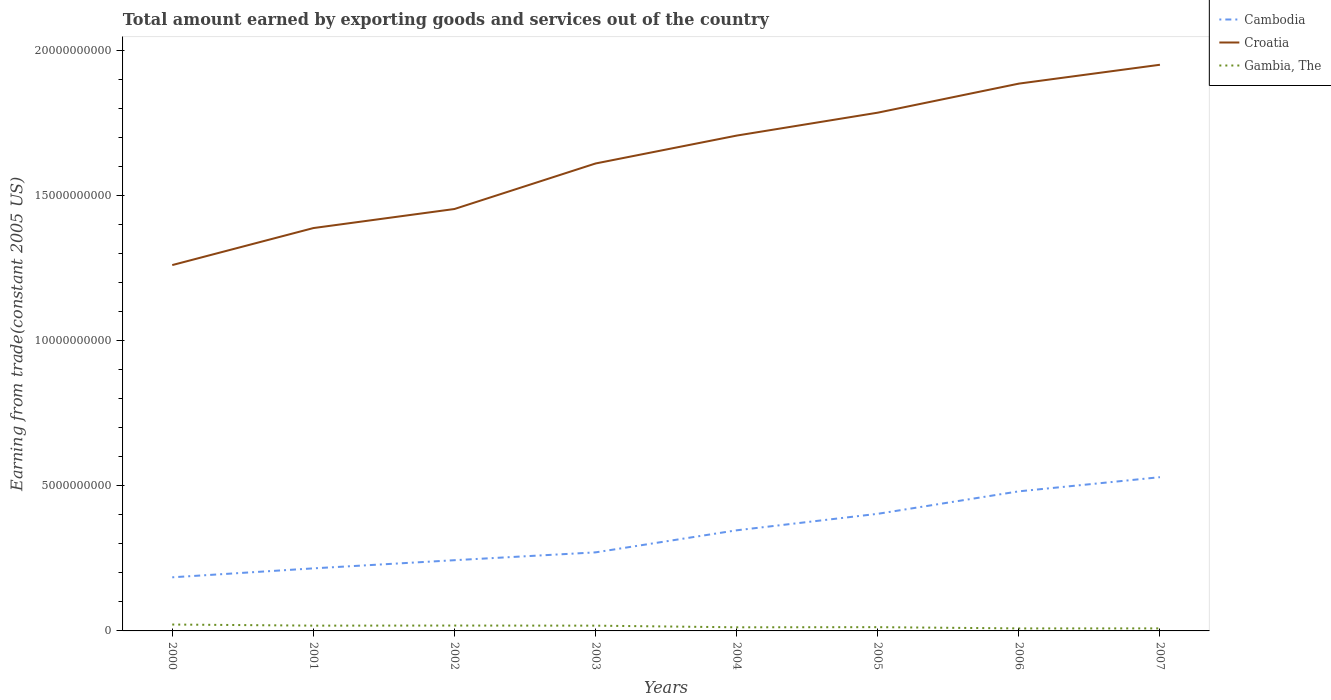How many different coloured lines are there?
Provide a short and direct response. 3. Does the line corresponding to Cambodia intersect with the line corresponding to Gambia, The?
Make the answer very short. No. Across all years, what is the maximum total amount earned by exporting goods and services in Croatia?
Give a very brief answer. 1.26e+1. In which year was the total amount earned by exporting goods and services in Gambia, The maximum?
Provide a short and direct response. 2006. What is the total total amount earned by exporting goods and services in Cambodia in the graph?
Provide a succinct answer. -3.08e+08. What is the difference between the highest and the second highest total amount earned by exporting goods and services in Gambia, The?
Give a very brief answer. 1.34e+08. What is the difference between the highest and the lowest total amount earned by exporting goods and services in Gambia, The?
Your answer should be very brief. 4. How many years are there in the graph?
Your answer should be compact. 8. What is the difference between two consecutive major ticks on the Y-axis?
Keep it short and to the point. 5.00e+09. Are the values on the major ticks of Y-axis written in scientific E-notation?
Provide a short and direct response. No. Does the graph contain any zero values?
Your response must be concise. No. How many legend labels are there?
Provide a short and direct response. 3. What is the title of the graph?
Offer a very short reply. Total amount earned by exporting goods and services out of the country. What is the label or title of the Y-axis?
Offer a very short reply. Earning from trade(constant 2005 US). What is the Earning from trade(constant 2005 US) in Cambodia in 2000?
Make the answer very short. 1.85e+09. What is the Earning from trade(constant 2005 US) in Croatia in 2000?
Your answer should be compact. 1.26e+1. What is the Earning from trade(constant 2005 US) of Gambia, The in 2000?
Give a very brief answer. 2.20e+08. What is the Earning from trade(constant 2005 US) in Cambodia in 2001?
Your response must be concise. 2.15e+09. What is the Earning from trade(constant 2005 US) in Croatia in 2001?
Provide a short and direct response. 1.39e+1. What is the Earning from trade(constant 2005 US) of Gambia, The in 2001?
Offer a very short reply. 1.82e+08. What is the Earning from trade(constant 2005 US) in Cambodia in 2002?
Ensure brevity in your answer.  2.44e+09. What is the Earning from trade(constant 2005 US) of Croatia in 2002?
Offer a terse response. 1.45e+1. What is the Earning from trade(constant 2005 US) of Gambia, The in 2002?
Keep it short and to the point. 1.85e+08. What is the Earning from trade(constant 2005 US) in Cambodia in 2003?
Offer a very short reply. 2.71e+09. What is the Earning from trade(constant 2005 US) of Croatia in 2003?
Offer a very short reply. 1.61e+1. What is the Earning from trade(constant 2005 US) of Gambia, The in 2003?
Keep it short and to the point. 1.81e+08. What is the Earning from trade(constant 2005 US) of Cambodia in 2004?
Your answer should be compact. 3.46e+09. What is the Earning from trade(constant 2005 US) in Croatia in 2004?
Provide a short and direct response. 1.71e+1. What is the Earning from trade(constant 2005 US) in Gambia, The in 2004?
Keep it short and to the point. 1.25e+08. What is the Earning from trade(constant 2005 US) in Cambodia in 2005?
Provide a short and direct response. 4.03e+09. What is the Earning from trade(constant 2005 US) of Croatia in 2005?
Provide a short and direct response. 1.78e+1. What is the Earning from trade(constant 2005 US) in Gambia, The in 2005?
Provide a short and direct response. 1.29e+08. What is the Earning from trade(constant 2005 US) in Cambodia in 2006?
Your answer should be very brief. 4.81e+09. What is the Earning from trade(constant 2005 US) of Croatia in 2006?
Provide a succinct answer. 1.88e+1. What is the Earning from trade(constant 2005 US) in Gambia, The in 2006?
Your answer should be compact. 8.66e+07. What is the Earning from trade(constant 2005 US) of Cambodia in 2007?
Your answer should be very brief. 5.29e+09. What is the Earning from trade(constant 2005 US) in Croatia in 2007?
Keep it short and to the point. 1.95e+1. What is the Earning from trade(constant 2005 US) in Gambia, The in 2007?
Your response must be concise. 8.70e+07. Across all years, what is the maximum Earning from trade(constant 2005 US) of Cambodia?
Keep it short and to the point. 5.29e+09. Across all years, what is the maximum Earning from trade(constant 2005 US) in Croatia?
Provide a succinct answer. 1.95e+1. Across all years, what is the maximum Earning from trade(constant 2005 US) in Gambia, The?
Provide a succinct answer. 2.20e+08. Across all years, what is the minimum Earning from trade(constant 2005 US) of Cambodia?
Offer a very short reply. 1.85e+09. Across all years, what is the minimum Earning from trade(constant 2005 US) of Croatia?
Your answer should be very brief. 1.26e+1. Across all years, what is the minimum Earning from trade(constant 2005 US) in Gambia, The?
Your answer should be compact. 8.66e+07. What is the total Earning from trade(constant 2005 US) in Cambodia in the graph?
Your response must be concise. 2.67e+1. What is the total Earning from trade(constant 2005 US) in Croatia in the graph?
Keep it short and to the point. 1.30e+11. What is the total Earning from trade(constant 2005 US) of Gambia, The in the graph?
Your response must be concise. 1.20e+09. What is the difference between the Earning from trade(constant 2005 US) in Cambodia in 2000 and that in 2001?
Give a very brief answer. -3.08e+08. What is the difference between the Earning from trade(constant 2005 US) of Croatia in 2000 and that in 2001?
Your response must be concise. -1.27e+09. What is the difference between the Earning from trade(constant 2005 US) of Gambia, The in 2000 and that in 2001?
Your answer should be very brief. 3.83e+07. What is the difference between the Earning from trade(constant 2005 US) in Cambodia in 2000 and that in 2002?
Ensure brevity in your answer.  -5.89e+08. What is the difference between the Earning from trade(constant 2005 US) in Croatia in 2000 and that in 2002?
Provide a short and direct response. -1.93e+09. What is the difference between the Earning from trade(constant 2005 US) of Gambia, The in 2000 and that in 2002?
Provide a succinct answer. 3.52e+07. What is the difference between the Earning from trade(constant 2005 US) of Cambodia in 2000 and that in 2003?
Ensure brevity in your answer.  -8.59e+08. What is the difference between the Earning from trade(constant 2005 US) of Croatia in 2000 and that in 2003?
Provide a succinct answer. -3.50e+09. What is the difference between the Earning from trade(constant 2005 US) of Gambia, The in 2000 and that in 2003?
Give a very brief answer. 3.89e+07. What is the difference between the Earning from trade(constant 2005 US) of Cambodia in 2000 and that in 2004?
Keep it short and to the point. -1.62e+09. What is the difference between the Earning from trade(constant 2005 US) in Croatia in 2000 and that in 2004?
Provide a succinct answer. -4.46e+09. What is the difference between the Earning from trade(constant 2005 US) of Gambia, The in 2000 and that in 2004?
Offer a terse response. 9.57e+07. What is the difference between the Earning from trade(constant 2005 US) in Cambodia in 2000 and that in 2005?
Offer a terse response. -2.19e+09. What is the difference between the Earning from trade(constant 2005 US) of Croatia in 2000 and that in 2005?
Ensure brevity in your answer.  -5.25e+09. What is the difference between the Earning from trade(constant 2005 US) in Gambia, The in 2000 and that in 2005?
Provide a succinct answer. 9.07e+07. What is the difference between the Earning from trade(constant 2005 US) in Cambodia in 2000 and that in 2006?
Provide a short and direct response. -2.96e+09. What is the difference between the Earning from trade(constant 2005 US) of Croatia in 2000 and that in 2006?
Provide a succinct answer. -6.25e+09. What is the difference between the Earning from trade(constant 2005 US) in Gambia, The in 2000 and that in 2006?
Offer a terse response. 1.34e+08. What is the difference between the Earning from trade(constant 2005 US) in Cambodia in 2000 and that in 2007?
Your answer should be compact. -3.45e+09. What is the difference between the Earning from trade(constant 2005 US) of Croatia in 2000 and that in 2007?
Ensure brevity in your answer.  -6.90e+09. What is the difference between the Earning from trade(constant 2005 US) in Gambia, The in 2000 and that in 2007?
Your response must be concise. 1.33e+08. What is the difference between the Earning from trade(constant 2005 US) of Cambodia in 2001 and that in 2002?
Your answer should be very brief. -2.81e+08. What is the difference between the Earning from trade(constant 2005 US) of Croatia in 2001 and that in 2002?
Your response must be concise. -6.56e+08. What is the difference between the Earning from trade(constant 2005 US) in Gambia, The in 2001 and that in 2002?
Give a very brief answer. -3.09e+06. What is the difference between the Earning from trade(constant 2005 US) of Cambodia in 2001 and that in 2003?
Your answer should be very brief. -5.51e+08. What is the difference between the Earning from trade(constant 2005 US) in Croatia in 2001 and that in 2003?
Offer a very short reply. -2.22e+09. What is the difference between the Earning from trade(constant 2005 US) in Gambia, The in 2001 and that in 2003?
Keep it short and to the point. 5.71e+05. What is the difference between the Earning from trade(constant 2005 US) in Cambodia in 2001 and that in 2004?
Make the answer very short. -1.31e+09. What is the difference between the Earning from trade(constant 2005 US) of Croatia in 2001 and that in 2004?
Offer a terse response. -3.18e+09. What is the difference between the Earning from trade(constant 2005 US) in Gambia, The in 2001 and that in 2004?
Give a very brief answer. 5.74e+07. What is the difference between the Earning from trade(constant 2005 US) of Cambodia in 2001 and that in 2005?
Offer a very short reply. -1.88e+09. What is the difference between the Earning from trade(constant 2005 US) in Croatia in 2001 and that in 2005?
Offer a terse response. -3.97e+09. What is the difference between the Earning from trade(constant 2005 US) in Gambia, The in 2001 and that in 2005?
Provide a short and direct response. 5.24e+07. What is the difference between the Earning from trade(constant 2005 US) of Cambodia in 2001 and that in 2006?
Your response must be concise. -2.65e+09. What is the difference between the Earning from trade(constant 2005 US) in Croatia in 2001 and that in 2006?
Your answer should be very brief. -4.97e+09. What is the difference between the Earning from trade(constant 2005 US) of Gambia, The in 2001 and that in 2006?
Offer a very short reply. 9.53e+07. What is the difference between the Earning from trade(constant 2005 US) in Cambodia in 2001 and that in 2007?
Give a very brief answer. -3.14e+09. What is the difference between the Earning from trade(constant 2005 US) in Croatia in 2001 and that in 2007?
Your answer should be very brief. -5.62e+09. What is the difference between the Earning from trade(constant 2005 US) of Gambia, The in 2001 and that in 2007?
Your answer should be compact. 9.49e+07. What is the difference between the Earning from trade(constant 2005 US) in Cambodia in 2002 and that in 2003?
Your answer should be very brief. -2.70e+08. What is the difference between the Earning from trade(constant 2005 US) of Croatia in 2002 and that in 2003?
Your answer should be compact. -1.57e+09. What is the difference between the Earning from trade(constant 2005 US) in Gambia, The in 2002 and that in 2003?
Provide a succinct answer. 3.66e+06. What is the difference between the Earning from trade(constant 2005 US) of Cambodia in 2002 and that in 2004?
Give a very brief answer. -1.03e+09. What is the difference between the Earning from trade(constant 2005 US) of Croatia in 2002 and that in 2004?
Keep it short and to the point. -2.53e+09. What is the difference between the Earning from trade(constant 2005 US) of Gambia, The in 2002 and that in 2004?
Make the answer very short. 6.05e+07. What is the difference between the Earning from trade(constant 2005 US) in Cambodia in 2002 and that in 2005?
Provide a succinct answer. -1.60e+09. What is the difference between the Earning from trade(constant 2005 US) of Croatia in 2002 and that in 2005?
Offer a very short reply. -3.32e+09. What is the difference between the Earning from trade(constant 2005 US) of Gambia, The in 2002 and that in 2005?
Your response must be concise. 5.55e+07. What is the difference between the Earning from trade(constant 2005 US) in Cambodia in 2002 and that in 2006?
Give a very brief answer. -2.37e+09. What is the difference between the Earning from trade(constant 2005 US) in Croatia in 2002 and that in 2006?
Offer a terse response. -4.32e+09. What is the difference between the Earning from trade(constant 2005 US) of Gambia, The in 2002 and that in 2006?
Your answer should be very brief. 9.84e+07. What is the difference between the Earning from trade(constant 2005 US) in Cambodia in 2002 and that in 2007?
Your response must be concise. -2.86e+09. What is the difference between the Earning from trade(constant 2005 US) of Croatia in 2002 and that in 2007?
Your response must be concise. -4.97e+09. What is the difference between the Earning from trade(constant 2005 US) in Gambia, The in 2002 and that in 2007?
Give a very brief answer. 9.80e+07. What is the difference between the Earning from trade(constant 2005 US) of Cambodia in 2003 and that in 2004?
Keep it short and to the point. -7.60e+08. What is the difference between the Earning from trade(constant 2005 US) in Croatia in 2003 and that in 2004?
Your response must be concise. -9.60e+08. What is the difference between the Earning from trade(constant 2005 US) in Gambia, The in 2003 and that in 2004?
Your answer should be very brief. 5.68e+07. What is the difference between the Earning from trade(constant 2005 US) of Cambodia in 2003 and that in 2005?
Keep it short and to the point. -1.33e+09. What is the difference between the Earning from trade(constant 2005 US) of Croatia in 2003 and that in 2005?
Provide a succinct answer. -1.75e+09. What is the difference between the Earning from trade(constant 2005 US) in Gambia, The in 2003 and that in 2005?
Keep it short and to the point. 5.18e+07. What is the difference between the Earning from trade(constant 2005 US) of Cambodia in 2003 and that in 2006?
Ensure brevity in your answer.  -2.10e+09. What is the difference between the Earning from trade(constant 2005 US) of Croatia in 2003 and that in 2006?
Keep it short and to the point. -2.75e+09. What is the difference between the Earning from trade(constant 2005 US) of Gambia, The in 2003 and that in 2006?
Ensure brevity in your answer.  9.48e+07. What is the difference between the Earning from trade(constant 2005 US) of Cambodia in 2003 and that in 2007?
Provide a short and direct response. -2.59e+09. What is the difference between the Earning from trade(constant 2005 US) in Croatia in 2003 and that in 2007?
Provide a short and direct response. -3.40e+09. What is the difference between the Earning from trade(constant 2005 US) of Gambia, The in 2003 and that in 2007?
Your answer should be very brief. 9.43e+07. What is the difference between the Earning from trade(constant 2005 US) of Cambodia in 2004 and that in 2005?
Your answer should be very brief. -5.68e+08. What is the difference between the Earning from trade(constant 2005 US) of Croatia in 2004 and that in 2005?
Ensure brevity in your answer.  -7.89e+08. What is the difference between the Earning from trade(constant 2005 US) of Gambia, The in 2004 and that in 2005?
Offer a very short reply. -4.98e+06. What is the difference between the Earning from trade(constant 2005 US) in Cambodia in 2004 and that in 2006?
Your answer should be compact. -1.34e+09. What is the difference between the Earning from trade(constant 2005 US) in Croatia in 2004 and that in 2006?
Provide a short and direct response. -1.79e+09. What is the difference between the Earning from trade(constant 2005 US) in Gambia, The in 2004 and that in 2006?
Offer a terse response. 3.80e+07. What is the difference between the Earning from trade(constant 2005 US) of Cambodia in 2004 and that in 2007?
Your response must be concise. -1.83e+09. What is the difference between the Earning from trade(constant 2005 US) in Croatia in 2004 and that in 2007?
Keep it short and to the point. -2.44e+09. What is the difference between the Earning from trade(constant 2005 US) of Gambia, The in 2004 and that in 2007?
Provide a short and direct response. 3.75e+07. What is the difference between the Earning from trade(constant 2005 US) of Cambodia in 2005 and that in 2006?
Offer a terse response. -7.74e+08. What is the difference between the Earning from trade(constant 2005 US) of Croatia in 2005 and that in 2006?
Offer a very short reply. -1.00e+09. What is the difference between the Earning from trade(constant 2005 US) of Gambia, The in 2005 and that in 2006?
Provide a succinct answer. 4.29e+07. What is the difference between the Earning from trade(constant 2005 US) in Cambodia in 2005 and that in 2007?
Keep it short and to the point. -1.26e+09. What is the difference between the Earning from trade(constant 2005 US) of Croatia in 2005 and that in 2007?
Give a very brief answer. -1.65e+09. What is the difference between the Earning from trade(constant 2005 US) of Gambia, The in 2005 and that in 2007?
Give a very brief answer. 4.25e+07. What is the difference between the Earning from trade(constant 2005 US) of Cambodia in 2006 and that in 2007?
Provide a succinct answer. -4.88e+08. What is the difference between the Earning from trade(constant 2005 US) of Croatia in 2006 and that in 2007?
Offer a terse response. -6.50e+08. What is the difference between the Earning from trade(constant 2005 US) in Gambia, The in 2006 and that in 2007?
Make the answer very short. -4.61e+05. What is the difference between the Earning from trade(constant 2005 US) of Cambodia in 2000 and the Earning from trade(constant 2005 US) of Croatia in 2001?
Offer a terse response. -1.20e+1. What is the difference between the Earning from trade(constant 2005 US) in Cambodia in 2000 and the Earning from trade(constant 2005 US) in Gambia, The in 2001?
Provide a succinct answer. 1.66e+09. What is the difference between the Earning from trade(constant 2005 US) in Croatia in 2000 and the Earning from trade(constant 2005 US) in Gambia, The in 2001?
Your answer should be very brief. 1.24e+1. What is the difference between the Earning from trade(constant 2005 US) in Cambodia in 2000 and the Earning from trade(constant 2005 US) in Croatia in 2002?
Provide a short and direct response. -1.27e+1. What is the difference between the Earning from trade(constant 2005 US) of Cambodia in 2000 and the Earning from trade(constant 2005 US) of Gambia, The in 2002?
Keep it short and to the point. 1.66e+09. What is the difference between the Earning from trade(constant 2005 US) in Croatia in 2000 and the Earning from trade(constant 2005 US) in Gambia, The in 2002?
Offer a very short reply. 1.24e+1. What is the difference between the Earning from trade(constant 2005 US) of Cambodia in 2000 and the Earning from trade(constant 2005 US) of Croatia in 2003?
Ensure brevity in your answer.  -1.43e+1. What is the difference between the Earning from trade(constant 2005 US) of Cambodia in 2000 and the Earning from trade(constant 2005 US) of Gambia, The in 2003?
Offer a terse response. 1.66e+09. What is the difference between the Earning from trade(constant 2005 US) of Croatia in 2000 and the Earning from trade(constant 2005 US) of Gambia, The in 2003?
Offer a terse response. 1.24e+1. What is the difference between the Earning from trade(constant 2005 US) of Cambodia in 2000 and the Earning from trade(constant 2005 US) of Croatia in 2004?
Provide a succinct answer. -1.52e+1. What is the difference between the Earning from trade(constant 2005 US) of Cambodia in 2000 and the Earning from trade(constant 2005 US) of Gambia, The in 2004?
Provide a short and direct response. 1.72e+09. What is the difference between the Earning from trade(constant 2005 US) of Croatia in 2000 and the Earning from trade(constant 2005 US) of Gambia, The in 2004?
Provide a succinct answer. 1.25e+1. What is the difference between the Earning from trade(constant 2005 US) in Cambodia in 2000 and the Earning from trade(constant 2005 US) in Croatia in 2005?
Ensure brevity in your answer.  -1.60e+1. What is the difference between the Earning from trade(constant 2005 US) of Cambodia in 2000 and the Earning from trade(constant 2005 US) of Gambia, The in 2005?
Provide a succinct answer. 1.72e+09. What is the difference between the Earning from trade(constant 2005 US) of Croatia in 2000 and the Earning from trade(constant 2005 US) of Gambia, The in 2005?
Offer a terse response. 1.25e+1. What is the difference between the Earning from trade(constant 2005 US) of Cambodia in 2000 and the Earning from trade(constant 2005 US) of Croatia in 2006?
Offer a terse response. -1.70e+1. What is the difference between the Earning from trade(constant 2005 US) of Cambodia in 2000 and the Earning from trade(constant 2005 US) of Gambia, The in 2006?
Provide a succinct answer. 1.76e+09. What is the difference between the Earning from trade(constant 2005 US) of Croatia in 2000 and the Earning from trade(constant 2005 US) of Gambia, The in 2006?
Provide a succinct answer. 1.25e+1. What is the difference between the Earning from trade(constant 2005 US) in Cambodia in 2000 and the Earning from trade(constant 2005 US) in Croatia in 2007?
Provide a short and direct response. -1.77e+1. What is the difference between the Earning from trade(constant 2005 US) of Cambodia in 2000 and the Earning from trade(constant 2005 US) of Gambia, The in 2007?
Keep it short and to the point. 1.76e+09. What is the difference between the Earning from trade(constant 2005 US) in Croatia in 2000 and the Earning from trade(constant 2005 US) in Gambia, The in 2007?
Your answer should be compact. 1.25e+1. What is the difference between the Earning from trade(constant 2005 US) of Cambodia in 2001 and the Earning from trade(constant 2005 US) of Croatia in 2002?
Provide a short and direct response. -1.24e+1. What is the difference between the Earning from trade(constant 2005 US) in Cambodia in 2001 and the Earning from trade(constant 2005 US) in Gambia, The in 2002?
Ensure brevity in your answer.  1.97e+09. What is the difference between the Earning from trade(constant 2005 US) in Croatia in 2001 and the Earning from trade(constant 2005 US) in Gambia, The in 2002?
Offer a terse response. 1.37e+1. What is the difference between the Earning from trade(constant 2005 US) of Cambodia in 2001 and the Earning from trade(constant 2005 US) of Croatia in 2003?
Offer a terse response. -1.39e+1. What is the difference between the Earning from trade(constant 2005 US) of Cambodia in 2001 and the Earning from trade(constant 2005 US) of Gambia, The in 2003?
Your answer should be compact. 1.97e+09. What is the difference between the Earning from trade(constant 2005 US) of Croatia in 2001 and the Earning from trade(constant 2005 US) of Gambia, The in 2003?
Keep it short and to the point. 1.37e+1. What is the difference between the Earning from trade(constant 2005 US) of Cambodia in 2001 and the Earning from trade(constant 2005 US) of Croatia in 2004?
Keep it short and to the point. -1.49e+1. What is the difference between the Earning from trade(constant 2005 US) of Cambodia in 2001 and the Earning from trade(constant 2005 US) of Gambia, The in 2004?
Your response must be concise. 2.03e+09. What is the difference between the Earning from trade(constant 2005 US) in Croatia in 2001 and the Earning from trade(constant 2005 US) in Gambia, The in 2004?
Ensure brevity in your answer.  1.37e+1. What is the difference between the Earning from trade(constant 2005 US) of Cambodia in 2001 and the Earning from trade(constant 2005 US) of Croatia in 2005?
Offer a terse response. -1.57e+1. What is the difference between the Earning from trade(constant 2005 US) in Cambodia in 2001 and the Earning from trade(constant 2005 US) in Gambia, The in 2005?
Provide a short and direct response. 2.02e+09. What is the difference between the Earning from trade(constant 2005 US) of Croatia in 2001 and the Earning from trade(constant 2005 US) of Gambia, The in 2005?
Provide a short and direct response. 1.37e+1. What is the difference between the Earning from trade(constant 2005 US) of Cambodia in 2001 and the Earning from trade(constant 2005 US) of Croatia in 2006?
Ensure brevity in your answer.  -1.67e+1. What is the difference between the Earning from trade(constant 2005 US) in Cambodia in 2001 and the Earning from trade(constant 2005 US) in Gambia, The in 2006?
Give a very brief answer. 2.07e+09. What is the difference between the Earning from trade(constant 2005 US) in Croatia in 2001 and the Earning from trade(constant 2005 US) in Gambia, The in 2006?
Offer a very short reply. 1.38e+1. What is the difference between the Earning from trade(constant 2005 US) of Cambodia in 2001 and the Earning from trade(constant 2005 US) of Croatia in 2007?
Your answer should be very brief. -1.73e+1. What is the difference between the Earning from trade(constant 2005 US) of Cambodia in 2001 and the Earning from trade(constant 2005 US) of Gambia, The in 2007?
Your response must be concise. 2.07e+09. What is the difference between the Earning from trade(constant 2005 US) of Croatia in 2001 and the Earning from trade(constant 2005 US) of Gambia, The in 2007?
Offer a terse response. 1.38e+1. What is the difference between the Earning from trade(constant 2005 US) in Cambodia in 2002 and the Earning from trade(constant 2005 US) in Croatia in 2003?
Ensure brevity in your answer.  -1.37e+1. What is the difference between the Earning from trade(constant 2005 US) of Cambodia in 2002 and the Earning from trade(constant 2005 US) of Gambia, The in 2003?
Keep it short and to the point. 2.25e+09. What is the difference between the Earning from trade(constant 2005 US) of Croatia in 2002 and the Earning from trade(constant 2005 US) of Gambia, The in 2003?
Your response must be concise. 1.43e+1. What is the difference between the Earning from trade(constant 2005 US) in Cambodia in 2002 and the Earning from trade(constant 2005 US) in Croatia in 2004?
Your answer should be very brief. -1.46e+1. What is the difference between the Earning from trade(constant 2005 US) of Cambodia in 2002 and the Earning from trade(constant 2005 US) of Gambia, The in 2004?
Ensure brevity in your answer.  2.31e+09. What is the difference between the Earning from trade(constant 2005 US) in Croatia in 2002 and the Earning from trade(constant 2005 US) in Gambia, The in 2004?
Keep it short and to the point. 1.44e+1. What is the difference between the Earning from trade(constant 2005 US) of Cambodia in 2002 and the Earning from trade(constant 2005 US) of Croatia in 2005?
Ensure brevity in your answer.  -1.54e+1. What is the difference between the Earning from trade(constant 2005 US) of Cambodia in 2002 and the Earning from trade(constant 2005 US) of Gambia, The in 2005?
Provide a succinct answer. 2.31e+09. What is the difference between the Earning from trade(constant 2005 US) in Croatia in 2002 and the Earning from trade(constant 2005 US) in Gambia, The in 2005?
Keep it short and to the point. 1.44e+1. What is the difference between the Earning from trade(constant 2005 US) of Cambodia in 2002 and the Earning from trade(constant 2005 US) of Croatia in 2006?
Your answer should be very brief. -1.64e+1. What is the difference between the Earning from trade(constant 2005 US) of Cambodia in 2002 and the Earning from trade(constant 2005 US) of Gambia, The in 2006?
Your response must be concise. 2.35e+09. What is the difference between the Earning from trade(constant 2005 US) of Croatia in 2002 and the Earning from trade(constant 2005 US) of Gambia, The in 2006?
Offer a very short reply. 1.44e+1. What is the difference between the Earning from trade(constant 2005 US) in Cambodia in 2002 and the Earning from trade(constant 2005 US) in Croatia in 2007?
Offer a terse response. -1.71e+1. What is the difference between the Earning from trade(constant 2005 US) of Cambodia in 2002 and the Earning from trade(constant 2005 US) of Gambia, The in 2007?
Make the answer very short. 2.35e+09. What is the difference between the Earning from trade(constant 2005 US) in Croatia in 2002 and the Earning from trade(constant 2005 US) in Gambia, The in 2007?
Keep it short and to the point. 1.44e+1. What is the difference between the Earning from trade(constant 2005 US) in Cambodia in 2003 and the Earning from trade(constant 2005 US) in Croatia in 2004?
Provide a succinct answer. -1.44e+1. What is the difference between the Earning from trade(constant 2005 US) in Cambodia in 2003 and the Earning from trade(constant 2005 US) in Gambia, The in 2004?
Keep it short and to the point. 2.58e+09. What is the difference between the Earning from trade(constant 2005 US) of Croatia in 2003 and the Earning from trade(constant 2005 US) of Gambia, The in 2004?
Keep it short and to the point. 1.60e+1. What is the difference between the Earning from trade(constant 2005 US) in Cambodia in 2003 and the Earning from trade(constant 2005 US) in Croatia in 2005?
Make the answer very short. -1.51e+1. What is the difference between the Earning from trade(constant 2005 US) in Cambodia in 2003 and the Earning from trade(constant 2005 US) in Gambia, The in 2005?
Give a very brief answer. 2.58e+09. What is the difference between the Earning from trade(constant 2005 US) of Croatia in 2003 and the Earning from trade(constant 2005 US) of Gambia, The in 2005?
Provide a short and direct response. 1.60e+1. What is the difference between the Earning from trade(constant 2005 US) of Cambodia in 2003 and the Earning from trade(constant 2005 US) of Croatia in 2006?
Provide a succinct answer. -1.61e+1. What is the difference between the Earning from trade(constant 2005 US) in Cambodia in 2003 and the Earning from trade(constant 2005 US) in Gambia, The in 2006?
Provide a short and direct response. 2.62e+09. What is the difference between the Earning from trade(constant 2005 US) of Croatia in 2003 and the Earning from trade(constant 2005 US) of Gambia, The in 2006?
Offer a terse response. 1.60e+1. What is the difference between the Earning from trade(constant 2005 US) in Cambodia in 2003 and the Earning from trade(constant 2005 US) in Croatia in 2007?
Make the answer very short. -1.68e+1. What is the difference between the Earning from trade(constant 2005 US) of Cambodia in 2003 and the Earning from trade(constant 2005 US) of Gambia, The in 2007?
Provide a succinct answer. 2.62e+09. What is the difference between the Earning from trade(constant 2005 US) of Croatia in 2003 and the Earning from trade(constant 2005 US) of Gambia, The in 2007?
Your answer should be compact. 1.60e+1. What is the difference between the Earning from trade(constant 2005 US) of Cambodia in 2004 and the Earning from trade(constant 2005 US) of Croatia in 2005?
Keep it short and to the point. -1.44e+1. What is the difference between the Earning from trade(constant 2005 US) in Cambodia in 2004 and the Earning from trade(constant 2005 US) in Gambia, The in 2005?
Provide a succinct answer. 3.34e+09. What is the difference between the Earning from trade(constant 2005 US) of Croatia in 2004 and the Earning from trade(constant 2005 US) of Gambia, The in 2005?
Give a very brief answer. 1.69e+1. What is the difference between the Earning from trade(constant 2005 US) in Cambodia in 2004 and the Earning from trade(constant 2005 US) in Croatia in 2006?
Give a very brief answer. -1.54e+1. What is the difference between the Earning from trade(constant 2005 US) in Cambodia in 2004 and the Earning from trade(constant 2005 US) in Gambia, The in 2006?
Your answer should be compact. 3.38e+09. What is the difference between the Earning from trade(constant 2005 US) in Croatia in 2004 and the Earning from trade(constant 2005 US) in Gambia, The in 2006?
Offer a terse response. 1.70e+1. What is the difference between the Earning from trade(constant 2005 US) in Cambodia in 2004 and the Earning from trade(constant 2005 US) in Croatia in 2007?
Make the answer very short. -1.60e+1. What is the difference between the Earning from trade(constant 2005 US) in Cambodia in 2004 and the Earning from trade(constant 2005 US) in Gambia, The in 2007?
Provide a succinct answer. 3.38e+09. What is the difference between the Earning from trade(constant 2005 US) in Croatia in 2004 and the Earning from trade(constant 2005 US) in Gambia, The in 2007?
Provide a short and direct response. 1.70e+1. What is the difference between the Earning from trade(constant 2005 US) in Cambodia in 2005 and the Earning from trade(constant 2005 US) in Croatia in 2006?
Give a very brief answer. -1.48e+1. What is the difference between the Earning from trade(constant 2005 US) of Cambodia in 2005 and the Earning from trade(constant 2005 US) of Gambia, The in 2006?
Keep it short and to the point. 3.95e+09. What is the difference between the Earning from trade(constant 2005 US) of Croatia in 2005 and the Earning from trade(constant 2005 US) of Gambia, The in 2006?
Ensure brevity in your answer.  1.78e+1. What is the difference between the Earning from trade(constant 2005 US) in Cambodia in 2005 and the Earning from trade(constant 2005 US) in Croatia in 2007?
Provide a short and direct response. -1.55e+1. What is the difference between the Earning from trade(constant 2005 US) of Cambodia in 2005 and the Earning from trade(constant 2005 US) of Gambia, The in 2007?
Make the answer very short. 3.95e+09. What is the difference between the Earning from trade(constant 2005 US) of Croatia in 2005 and the Earning from trade(constant 2005 US) of Gambia, The in 2007?
Your response must be concise. 1.78e+1. What is the difference between the Earning from trade(constant 2005 US) of Cambodia in 2006 and the Earning from trade(constant 2005 US) of Croatia in 2007?
Provide a succinct answer. -1.47e+1. What is the difference between the Earning from trade(constant 2005 US) in Cambodia in 2006 and the Earning from trade(constant 2005 US) in Gambia, The in 2007?
Ensure brevity in your answer.  4.72e+09. What is the difference between the Earning from trade(constant 2005 US) of Croatia in 2006 and the Earning from trade(constant 2005 US) of Gambia, The in 2007?
Your answer should be very brief. 1.88e+1. What is the average Earning from trade(constant 2005 US) in Cambodia per year?
Keep it short and to the point. 3.34e+09. What is the average Earning from trade(constant 2005 US) in Croatia per year?
Provide a short and direct response. 1.63e+1. What is the average Earning from trade(constant 2005 US) in Gambia, The per year?
Ensure brevity in your answer.  1.49e+08. In the year 2000, what is the difference between the Earning from trade(constant 2005 US) in Cambodia and Earning from trade(constant 2005 US) in Croatia?
Make the answer very short. -1.08e+1. In the year 2000, what is the difference between the Earning from trade(constant 2005 US) in Cambodia and Earning from trade(constant 2005 US) in Gambia, The?
Keep it short and to the point. 1.63e+09. In the year 2000, what is the difference between the Earning from trade(constant 2005 US) of Croatia and Earning from trade(constant 2005 US) of Gambia, The?
Provide a short and direct response. 1.24e+1. In the year 2001, what is the difference between the Earning from trade(constant 2005 US) in Cambodia and Earning from trade(constant 2005 US) in Croatia?
Your answer should be very brief. -1.17e+1. In the year 2001, what is the difference between the Earning from trade(constant 2005 US) in Cambodia and Earning from trade(constant 2005 US) in Gambia, The?
Give a very brief answer. 1.97e+09. In the year 2001, what is the difference between the Earning from trade(constant 2005 US) of Croatia and Earning from trade(constant 2005 US) of Gambia, The?
Keep it short and to the point. 1.37e+1. In the year 2002, what is the difference between the Earning from trade(constant 2005 US) of Cambodia and Earning from trade(constant 2005 US) of Croatia?
Your answer should be very brief. -1.21e+1. In the year 2002, what is the difference between the Earning from trade(constant 2005 US) of Cambodia and Earning from trade(constant 2005 US) of Gambia, The?
Ensure brevity in your answer.  2.25e+09. In the year 2002, what is the difference between the Earning from trade(constant 2005 US) of Croatia and Earning from trade(constant 2005 US) of Gambia, The?
Ensure brevity in your answer.  1.43e+1. In the year 2003, what is the difference between the Earning from trade(constant 2005 US) of Cambodia and Earning from trade(constant 2005 US) of Croatia?
Your answer should be very brief. -1.34e+1. In the year 2003, what is the difference between the Earning from trade(constant 2005 US) of Cambodia and Earning from trade(constant 2005 US) of Gambia, The?
Give a very brief answer. 2.52e+09. In the year 2003, what is the difference between the Earning from trade(constant 2005 US) of Croatia and Earning from trade(constant 2005 US) of Gambia, The?
Your response must be concise. 1.59e+1. In the year 2004, what is the difference between the Earning from trade(constant 2005 US) of Cambodia and Earning from trade(constant 2005 US) of Croatia?
Provide a succinct answer. -1.36e+1. In the year 2004, what is the difference between the Earning from trade(constant 2005 US) of Cambodia and Earning from trade(constant 2005 US) of Gambia, The?
Your answer should be very brief. 3.34e+09. In the year 2004, what is the difference between the Earning from trade(constant 2005 US) in Croatia and Earning from trade(constant 2005 US) in Gambia, The?
Your answer should be very brief. 1.69e+1. In the year 2005, what is the difference between the Earning from trade(constant 2005 US) of Cambodia and Earning from trade(constant 2005 US) of Croatia?
Make the answer very short. -1.38e+1. In the year 2005, what is the difference between the Earning from trade(constant 2005 US) of Cambodia and Earning from trade(constant 2005 US) of Gambia, The?
Ensure brevity in your answer.  3.90e+09. In the year 2005, what is the difference between the Earning from trade(constant 2005 US) in Croatia and Earning from trade(constant 2005 US) in Gambia, The?
Provide a short and direct response. 1.77e+1. In the year 2006, what is the difference between the Earning from trade(constant 2005 US) of Cambodia and Earning from trade(constant 2005 US) of Croatia?
Offer a terse response. -1.40e+1. In the year 2006, what is the difference between the Earning from trade(constant 2005 US) in Cambodia and Earning from trade(constant 2005 US) in Gambia, The?
Your answer should be compact. 4.72e+09. In the year 2006, what is the difference between the Earning from trade(constant 2005 US) in Croatia and Earning from trade(constant 2005 US) in Gambia, The?
Your answer should be very brief. 1.88e+1. In the year 2007, what is the difference between the Earning from trade(constant 2005 US) in Cambodia and Earning from trade(constant 2005 US) in Croatia?
Provide a succinct answer. -1.42e+1. In the year 2007, what is the difference between the Earning from trade(constant 2005 US) of Cambodia and Earning from trade(constant 2005 US) of Gambia, The?
Provide a short and direct response. 5.21e+09. In the year 2007, what is the difference between the Earning from trade(constant 2005 US) in Croatia and Earning from trade(constant 2005 US) in Gambia, The?
Make the answer very short. 1.94e+1. What is the ratio of the Earning from trade(constant 2005 US) in Cambodia in 2000 to that in 2001?
Your answer should be compact. 0.86. What is the ratio of the Earning from trade(constant 2005 US) in Croatia in 2000 to that in 2001?
Provide a short and direct response. 0.91. What is the ratio of the Earning from trade(constant 2005 US) in Gambia, The in 2000 to that in 2001?
Provide a succinct answer. 1.21. What is the ratio of the Earning from trade(constant 2005 US) of Cambodia in 2000 to that in 2002?
Provide a short and direct response. 0.76. What is the ratio of the Earning from trade(constant 2005 US) in Croatia in 2000 to that in 2002?
Provide a succinct answer. 0.87. What is the ratio of the Earning from trade(constant 2005 US) in Gambia, The in 2000 to that in 2002?
Provide a short and direct response. 1.19. What is the ratio of the Earning from trade(constant 2005 US) of Cambodia in 2000 to that in 2003?
Offer a terse response. 0.68. What is the ratio of the Earning from trade(constant 2005 US) in Croatia in 2000 to that in 2003?
Ensure brevity in your answer.  0.78. What is the ratio of the Earning from trade(constant 2005 US) of Gambia, The in 2000 to that in 2003?
Offer a very short reply. 1.21. What is the ratio of the Earning from trade(constant 2005 US) of Cambodia in 2000 to that in 2004?
Keep it short and to the point. 0.53. What is the ratio of the Earning from trade(constant 2005 US) in Croatia in 2000 to that in 2004?
Offer a terse response. 0.74. What is the ratio of the Earning from trade(constant 2005 US) in Gambia, The in 2000 to that in 2004?
Provide a succinct answer. 1.77. What is the ratio of the Earning from trade(constant 2005 US) in Cambodia in 2000 to that in 2005?
Ensure brevity in your answer.  0.46. What is the ratio of the Earning from trade(constant 2005 US) in Croatia in 2000 to that in 2005?
Provide a short and direct response. 0.71. What is the ratio of the Earning from trade(constant 2005 US) in Gambia, The in 2000 to that in 2005?
Provide a succinct answer. 1.7. What is the ratio of the Earning from trade(constant 2005 US) of Cambodia in 2000 to that in 2006?
Offer a very short reply. 0.38. What is the ratio of the Earning from trade(constant 2005 US) in Croatia in 2000 to that in 2006?
Make the answer very short. 0.67. What is the ratio of the Earning from trade(constant 2005 US) of Gambia, The in 2000 to that in 2006?
Keep it short and to the point. 2.54. What is the ratio of the Earning from trade(constant 2005 US) in Cambodia in 2000 to that in 2007?
Your response must be concise. 0.35. What is the ratio of the Earning from trade(constant 2005 US) in Croatia in 2000 to that in 2007?
Your answer should be very brief. 0.65. What is the ratio of the Earning from trade(constant 2005 US) of Gambia, The in 2000 to that in 2007?
Your response must be concise. 2.53. What is the ratio of the Earning from trade(constant 2005 US) in Cambodia in 2001 to that in 2002?
Ensure brevity in your answer.  0.88. What is the ratio of the Earning from trade(constant 2005 US) in Croatia in 2001 to that in 2002?
Give a very brief answer. 0.95. What is the ratio of the Earning from trade(constant 2005 US) of Gambia, The in 2001 to that in 2002?
Your answer should be very brief. 0.98. What is the ratio of the Earning from trade(constant 2005 US) in Cambodia in 2001 to that in 2003?
Make the answer very short. 0.8. What is the ratio of the Earning from trade(constant 2005 US) in Croatia in 2001 to that in 2003?
Offer a terse response. 0.86. What is the ratio of the Earning from trade(constant 2005 US) in Cambodia in 2001 to that in 2004?
Your response must be concise. 0.62. What is the ratio of the Earning from trade(constant 2005 US) of Croatia in 2001 to that in 2004?
Offer a very short reply. 0.81. What is the ratio of the Earning from trade(constant 2005 US) in Gambia, The in 2001 to that in 2004?
Make the answer very short. 1.46. What is the ratio of the Earning from trade(constant 2005 US) of Cambodia in 2001 to that in 2005?
Provide a succinct answer. 0.53. What is the ratio of the Earning from trade(constant 2005 US) of Croatia in 2001 to that in 2005?
Provide a short and direct response. 0.78. What is the ratio of the Earning from trade(constant 2005 US) in Gambia, The in 2001 to that in 2005?
Provide a succinct answer. 1.4. What is the ratio of the Earning from trade(constant 2005 US) in Cambodia in 2001 to that in 2006?
Offer a very short reply. 0.45. What is the ratio of the Earning from trade(constant 2005 US) in Croatia in 2001 to that in 2006?
Offer a terse response. 0.74. What is the ratio of the Earning from trade(constant 2005 US) in Gambia, The in 2001 to that in 2006?
Ensure brevity in your answer.  2.1. What is the ratio of the Earning from trade(constant 2005 US) of Cambodia in 2001 to that in 2007?
Ensure brevity in your answer.  0.41. What is the ratio of the Earning from trade(constant 2005 US) in Croatia in 2001 to that in 2007?
Provide a short and direct response. 0.71. What is the ratio of the Earning from trade(constant 2005 US) in Gambia, The in 2001 to that in 2007?
Your answer should be very brief. 2.09. What is the ratio of the Earning from trade(constant 2005 US) of Cambodia in 2002 to that in 2003?
Ensure brevity in your answer.  0.9. What is the ratio of the Earning from trade(constant 2005 US) of Croatia in 2002 to that in 2003?
Offer a terse response. 0.9. What is the ratio of the Earning from trade(constant 2005 US) in Gambia, The in 2002 to that in 2003?
Your answer should be very brief. 1.02. What is the ratio of the Earning from trade(constant 2005 US) of Cambodia in 2002 to that in 2004?
Provide a short and direct response. 0.7. What is the ratio of the Earning from trade(constant 2005 US) of Croatia in 2002 to that in 2004?
Your answer should be compact. 0.85. What is the ratio of the Earning from trade(constant 2005 US) in Gambia, The in 2002 to that in 2004?
Provide a succinct answer. 1.49. What is the ratio of the Earning from trade(constant 2005 US) in Cambodia in 2002 to that in 2005?
Ensure brevity in your answer.  0.6. What is the ratio of the Earning from trade(constant 2005 US) of Croatia in 2002 to that in 2005?
Your response must be concise. 0.81. What is the ratio of the Earning from trade(constant 2005 US) of Gambia, The in 2002 to that in 2005?
Your answer should be compact. 1.43. What is the ratio of the Earning from trade(constant 2005 US) of Cambodia in 2002 to that in 2006?
Provide a short and direct response. 0.51. What is the ratio of the Earning from trade(constant 2005 US) in Croatia in 2002 to that in 2006?
Keep it short and to the point. 0.77. What is the ratio of the Earning from trade(constant 2005 US) of Gambia, The in 2002 to that in 2006?
Provide a succinct answer. 2.14. What is the ratio of the Earning from trade(constant 2005 US) of Cambodia in 2002 to that in 2007?
Offer a very short reply. 0.46. What is the ratio of the Earning from trade(constant 2005 US) of Croatia in 2002 to that in 2007?
Offer a terse response. 0.75. What is the ratio of the Earning from trade(constant 2005 US) of Gambia, The in 2002 to that in 2007?
Give a very brief answer. 2.13. What is the ratio of the Earning from trade(constant 2005 US) of Cambodia in 2003 to that in 2004?
Your answer should be very brief. 0.78. What is the ratio of the Earning from trade(constant 2005 US) in Croatia in 2003 to that in 2004?
Offer a terse response. 0.94. What is the ratio of the Earning from trade(constant 2005 US) in Gambia, The in 2003 to that in 2004?
Ensure brevity in your answer.  1.46. What is the ratio of the Earning from trade(constant 2005 US) in Cambodia in 2003 to that in 2005?
Ensure brevity in your answer.  0.67. What is the ratio of the Earning from trade(constant 2005 US) of Croatia in 2003 to that in 2005?
Keep it short and to the point. 0.9. What is the ratio of the Earning from trade(constant 2005 US) of Gambia, The in 2003 to that in 2005?
Offer a terse response. 1.4. What is the ratio of the Earning from trade(constant 2005 US) in Cambodia in 2003 to that in 2006?
Your answer should be very brief. 0.56. What is the ratio of the Earning from trade(constant 2005 US) in Croatia in 2003 to that in 2006?
Your response must be concise. 0.85. What is the ratio of the Earning from trade(constant 2005 US) in Gambia, The in 2003 to that in 2006?
Your answer should be very brief. 2.09. What is the ratio of the Earning from trade(constant 2005 US) of Cambodia in 2003 to that in 2007?
Provide a short and direct response. 0.51. What is the ratio of the Earning from trade(constant 2005 US) in Croatia in 2003 to that in 2007?
Make the answer very short. 0.83. What is the ratio of the Earning from trade(constant 2005 US) in Gambia, The in 2003 to that in 2007?
Your answer should be very brief. 2.08. What is the ratio of the Earning from trade(constant 2005 US) of Cambodia in 2004 to that in 2005?
Give a very brief answer. 0.86. What is the ratio of the Earning from trade(constant 2005 US) of Croatia in 2004 to that in 2005?
Your response must be concise. 0.96. What is the ratio of the Earning from trade(constant 2005 US) in Gambia, The in 2004 to that in 2005?
Provide a short and direct response. 0.96. What is the ratio of the Earning from trade(constant 2005 US) of Cambodia in 2004 to that in 2006?
Give a very brief answer. 0.72. What is the ratio of the Earning from trade(constant 2005 US) of Croatia in 2004 to that in 2006?
Ensure brevity in your answer.  0.91. What is the ratio of the Earning from trade(constant 2005 US) in Gambia, The in 2004 to that in 2006?
Give a very brief answer. 1.44. What is the ratio of the Earning from trade(constant 2005 US) of Cambodia in 2004 to that in 2007?
Give a very brief answer. 0.65. What is the ratio of the Earning from trade(constant 2005 US) in Croatia in 2004 to that in 2007?
Give a very brief answer. 0.87. What is the ratio of the Earning from trade(constant 2005 US) in Gambia, The in 2004 to that in 2007?
Provide a short and direct response. 1.43. What is the ratio of the Earning from trade(constant 2005 US) in Cambodia in 2005 to that in 2006?
Keep it short and to the point. 0.84. What is the ratio of the Earning from trade(constant 2005 US) in Croatia in 2005 to that in 2006?
Your response must be concise. 0.95. What is the ratio of the Earning from trade(constant 2005 US) of Gambia, The in 2005 to that in 2006?
Make the answer very short. 1.5. What is the ratio of the Earning from trade(constant 2005 US) in Cambodia in 2005 to that in 2007?
Offer a terse response. 0.76. What is the ratio of the Earning from trade(constant 2005 US) of Croatia in 2005 to that in 2007?
Ensure brevity in your answer.  0.92. What is the ratio of the Earning from trade(constant 2005 US) of Gambia, The in 2005 to that in 2007?
Offer a very short reply. 1.49. What is the ratio of the Earning from trade(constant 2005 US) of Cambodia in 2006 to that in 2007?
Your answer should be very brief. 0.91. What is the ratio of the Earning from trade(constant 2005 US) in Croatia in 2006 to that in 2007?
Make the answer very short. 0.97. What is the difference between the highest and the second highest Earning from trade(constant 2005 US) of Cambodia?
Give a very brief answer. 4.88e+08. What is the difference between the highest and the second highest Earning from trade(constant 2005 US) of Croatia?
Ensure brevity in your answer.  6.50e+08. What is the difference between the highest and the second highest Earning from trade(constant 2005 US) in Gambia, The?
Your response must be concise. 3.52e+07. What is the difference between the highest and the lowest Earning from trade(constant 2005 US) in Cambodia?
Offer a very short reply. 3.45e+09. What is the difference between the highest and the lowest Earning from trade(constant 2005 US) in Croatia?
Make the answer very short. 6.90e+09. What is the difference between the highest and the lowest Earning from trade(constant 2005 US) of Gambia, The?
Make the answer very short. 1.34e+08. 